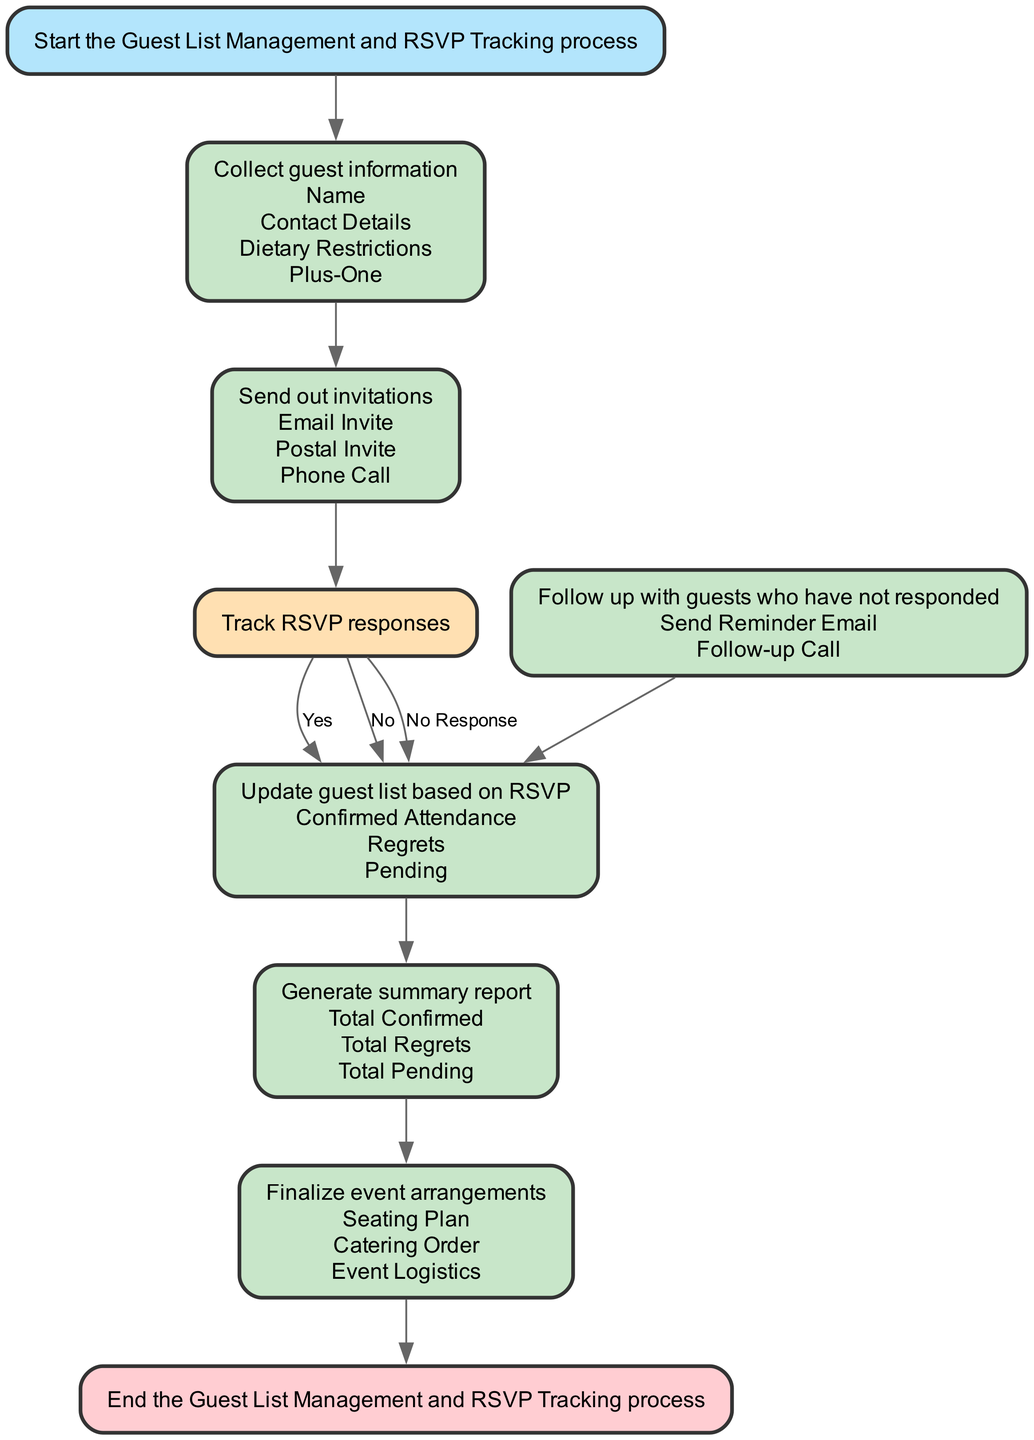What is the first step in the process? The first step in the diagram is labeled "Start the Guest List Management and RSVP Tracking process" and is represented by the 'start' node.
Answer: Start the Guest List Management and RSVP Tracking process How many types of invitations are there? The 'send_invitations' process lists three types of invitations: Email Invite, Postal Invite, and Phone Call.
Answer: Three What happens if a guest does not respond? If a guest does not respond, the flow directs to the 'follow_up_no_response' process, which includes actions like sending a reminder email and making follow-up calls.
Answer: Follow up with guests who have not responded What are the outcomes after tracking RSVP? After tracking RSVP, the flow determines three possible outcomes: Yes, No, and No Response, leading to different subsequent actions.
Answer: Yes, No, No Response What is generated after updating the guest list? After updating the guest list, the next step is to 'generate summary report', which summarizes attendance information.
Answer: Generate summary report What is the final step in the flow? The final step in the diagram is labeled "End the Guest List Management and RSVP Tracking process," which indicates the conclusion of this workflow.
Answer: End the Guest List Management and RSVP Tracking process How many process nodes are in the diagram? The diagram has five process nodes: Collect guest information, Send out invitations, Follow up with guests who have not responded, Update guest list based on RSVP, and Finalize event arrangements.
Answer: Five What does the node 'track_rsvp' represent? The 'track_rsvp' node represents a decision point where the responses from invited guests are assessed to determine their attendance status.
Answer: A decision point for RSVP responses What is included in the 'finalize_arrangements' step? The 'finalize_arrangements' step includes preparing the seating plan, catering order, and event logistics, as indicated in the flowchart.
Answer: Seating Plan, Catering Order, Event Logistics 